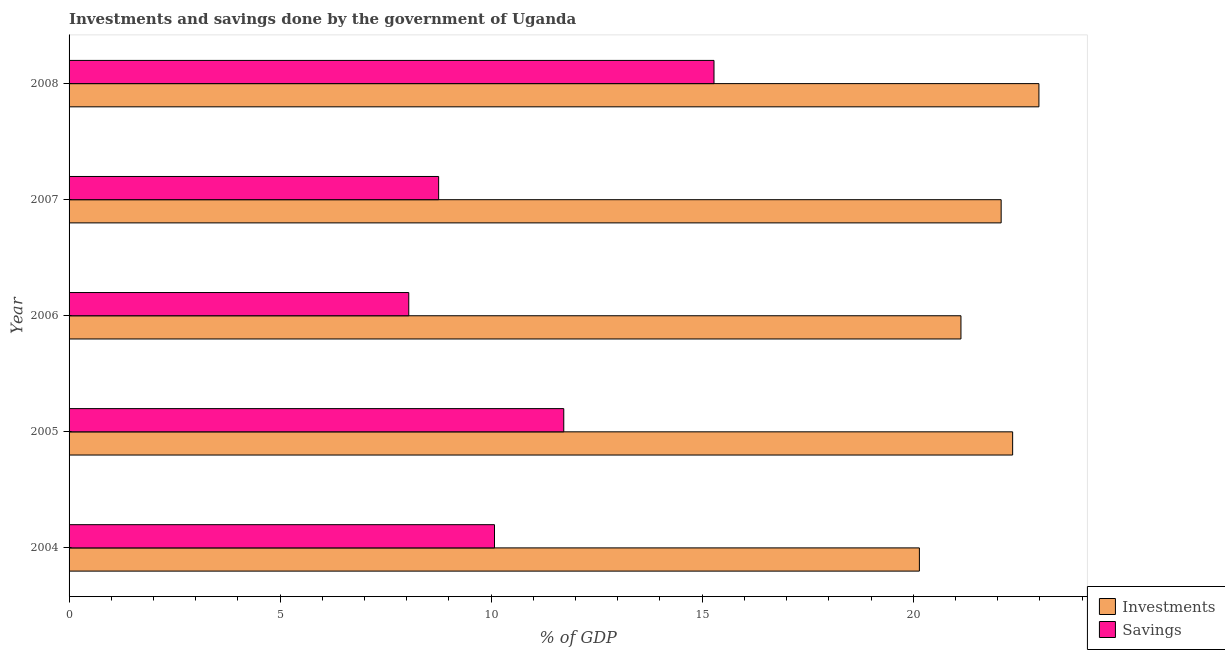How many different coloured bars are there?
Keep it short and to the point. 2. Are the number of bars per tick equal to the number of legend labels?
Keep it short and to the point. Yes. Are the number of bars on each tick of the Y-axis equal?
Offer a very short reply. Yes. How many bars are there on the 1st tick from the bottom?
Your answer should be compact. 2. What is the savings of government in 2004?
Ensure brevity in your answer.  10.08. Across all years, what is the maximum savings of government?
Your answer should be very brief. 15.28. Across all years, what is the minimum savings of government?
Make the answer very short. 8.05. In which year was the savings of government maximum?
Make the answer very short. 2008. In which year was the investments of government minimum?
Provide a succinct answer. 2004. What is the total investments of government in the graph?
Your response must be concise. 108.69. What is the difference between the investments of government in 2005 and that in 2006?
Give a very brief answer. 1.23. What is the difference between the investments of government in 2008 and the savings of government in 2004?
Your answer should be very brief. 12.9. What is the average savings of government per year?
Keep it short and to the point. 10.78. In the year 2008, what is the difference between the investments of government and savings of government?
Keep it short and to the point. 7.7. What is the ratio of the savings of government in 2004 to that in 2008?
Keep it short and to the point. 0.66. What is the difference between the highest and the second highest savings of government?
Make the answer very short. 3.56. What is the difference between the highest and the lowest savings of government?
Offer a very short reply. 7.23. In how many years, is the investments of government greater than the average investments of government taken over all years?
Give a very brief answer. 3. Is the sum of the savings of government in 2006 and 2008 greater than the maximum investments of government across all years?
Your answer should be very brief. Yes. What does the 2nd bar from the top in 2005 represents?
Keep it short and to the point. Investments. What does the 2nd bar from the bottom in 2005 represents?
Give a very brief answer. Savings. How many bars are there?
Give a very brief answer. 10. Are all the bars in the graph horizontal?
Your response must be concise. Yes. Are the values on the major ticks of X-axis written in scientific E-notation?
Provide a short and direct response. No. Does the graph contain grids?
Your answer should be very brief. No. Where does the legend appear in the graph?
Your answer should be compact. Bottom right. How many legend labels are there?
Provide a succinct answer. 2. What is the title of the graph?
Your answer should be very brief. Investments and savings done by the government of Uganda. Does "Nitrous oxide emissions" appear as one of the legend labels in the graph?
Your answer should be very brief. No. What is the label or title of the X-axis?
Your answer should be compact. % of GDP. What is the label or title of the Y-axis?
Give a very brief answer. Year. What is the % of GDP of Investments in 2004?
Your answer should be compact. 20.15. What is the % of GDP in Savings in 2004?
Provide a succinct answer. 10.08. What is the % of GDP of Investments in 2005?
Ensure brevity in your answer.  22.36. What is the % of GDP of Savings in 2005?
Offer a terse response. 11.72. What is the % of GDP in Investments in 2006?
Make the answer very short. 21.13. What is the % of GDP in Savings in 2006?
Keep it short and to the point. 8.05. What is the % of GDP in Investments in 2007?
Provide a short and direct response. 22.08. What is the % of GDP in Savings in 2007?
Keep it short and to the point. 8.76. What is the % of GDP in Investments in 2008?
Your answer should be very brief. 22.98. What is the % of GDP of Savings in 2008?
Give a very brief answer. 15.28. Across all years, what is the maximum % of GDP in Investments?
Provide a succinct answer. 22.98. Across all years, what is the maximum % of GDP in Savings?
Make the answer very short. 15.28. Across all years, what is the minimum % of GDP of Investments?
Offer a terse response. 20.15. Across all years, what is the minimum % of GDP of Savings?
Make the answer very short. 8.05. What is the total % of GDP of Investments in the graph?
Your answer should be compact. 108.69. What is the total % of GDP in Savings in the graph?
Ensure brevity in your answer.  53.88. What is the difference between the % of GDP of Investments in 2004 and that in 2005?
Make the answer very short. -2.21. What is the difference between the % of GDP of Savings in 2004 and that in 2005?
Your response must be concise. -1.64. What is the difference between the % of GDP of Investments in 2004 and that in 2006?
Ensure brevity in your answer.  -0.98. What is the difference between the % of GDP of Savings in 2004 and that in 2006?
Give a very brief answer. 2.03. What is the difference between the % of GDP in Investments in 2004 and that in 2007?
Ensure brevity in your answer.  -1.94. What is the difference between the % of GDP of Savings in 2004 and that in 2007?
Your response must be concise. 1.32. What is the difference between the % of GDP in Investments in 2004 and that in 2008?
Make the answer very short. -2.83. What is the difference between the % of GDP in Savings in 2004 and that in 2008?
Your response must be concise. -5.2. What is the difference between the % of GDP in Investments in 2005 and that in 2006?
Provide a succinct answer. 1.22. What is the difference between the % of GDP of Savings in 2005 and that in 2006?
Provide a short and direct response. 3.67. What is the difference between the % of GDP in Investments in 2005 and that in 2007?
Give a very brief answer. 0.27. What is the difference between the % of GDP in Savings in 2005 and that in 2007?
Provide a short and direct response. 2.96. What is the difference between the % of GDP in Investments in 2005 and that in 2008?
Give a very brief answer. -0.62. What is the difference between the % of GDP in Savings in 2005 and that in 2008?
Offer a very short reply. -3.56. What is the difference between the % of GDP of Investments in 2006 and that in 2007?
Provide a short and direct response. -0.95. What is the difference between the % of GDP of Savings in 2006 and that in 2007?
Provide a succinct answer. -0.71. What is the difference between the % of GDP of Investments in 2006 and that in 2008?
Your answer should be compact. -1.85. What is the difference between the % of GDP of Savings in 2006 and that in 2008?
Make the answer very short. -7.23. What is the difference between the % of GDP in Investments in 2007 and that in 2008?
Offer a very short reply. -0.89. What is the difference between the % of GDP of Savings in 2007 and that in 2008?
Give a very brief answer. -6.52. What is the difference between the % of GDP of Investments in 2004 and the % of GDP of Savings in 2005?
Ensure brevity in your answer.  8.43. What is the difference between the % of GDP in Investments in 2004 and the % of GDP in Savings in 2006?
Offer a very short reply. 12.1. What is the difference between the % of GDP of Investments in 2004 and the % of GDP of Savings in 2007?
Give a very brief answer. 11.39. What is the difference between the % of GDP of Investments in 2004 and the % of GDP of Savings in 2008?
Give a very brief answer. 4.87. What is the difference between the % of GDP in Investments in 2005 and the % of GDP in Savings in 2006?
Offer a very short reply. 14.31. What is the difference between the % of GDP in Investments in 2005 and the % of GDP in Savings in 2007?
Your answer should be very brief. 13.6. What is the difference between the % of GDP of Investments in 2005 and the % of GDP of Savings in 2008?
Keep it short and to the point. 7.08. What is the difference between the % of GDP in Investments in 2006 and the % of GDP in Savings in 2007?
Offer a terse response. 12.37. What is the difference between the % of GDP in Investments in 2006 and the % of GDP in Savings in 2008?
Your answer should be very brief. 5.85. What is the difference between the % of GDP in Investments in 2007 and the % of GDP in Savings in 2008?
Offer a very short reply. 6.8. What is the average % of GDP in Investments per year?
Provide a succinct answer. 21.74. What is the average % of GDP of Savings per year?
Offer a terse response. 10.78. In the year 2004, what is the difference between the % of GDP of Investments and % of GDP of Savings?
Ensure brevity in your answer.  10.07. In the year 2005, what is the difference between the % of GDP of Investments and % of GDP of Savings?
Provide a short and direct response. 10.63. In the year 2006, what is the difference between the % of GDP of Investments and % of GDP of Savings?
Your answer should be very brief. 13.08. In the year 2007, what is the difference between the % of GDP of Investments and % of GDP of Savings?
Your answer should be compact. 13.33. In the year 2008, what is the difference between the % of GDP in Investments and % of GDP in Savings?
Make the answer very short. 7.7. What is the ratio of the % of GDP in Investments in 2004 to that in 2005?
Provide a succinct answer. 0.9. What is the ratio of the % of GDP of Savings in 2004 to that in 2005?
Your response must be concise. 0.86. What is the ratio of the % of GDP in Investments in 2004 to that in 2006?
Make the answer very short. 0.95. What is the ratio of the % of GDP in Savings in 2004 to that in 2006?
Make the answer very short. 1.25. What is the ratio of the % of GDP of Investments in 2004 to that in 2007?
Give a very brief answer. 0.91. What is the ratio of the % of GDP in Savings in 2004 to that in 2007?
Provide a succinct answer. 1.15. What is the ratio of the % of GDP of Investments in 2004 to that in 2008?
Offer a terse response. 0.88. What is the ratio of the % of GDP of Savings in 2004 to that in 2008?
Your answer should be very brief. 0.66. What is the ratio of the % of GDP in Investments in 2005 to that in 2006?
Keep it short and to the point. 1.06. What is the ratio of the % of GDP of Savings in 2005 to that in 2006?
Provide a short and direct response. 1.46. What is the ratio of the % of GDP in Investments in 2005 to that in 2007?
Your response must be concise. 1.01. What is the ratio of the % of GDP of Savings in 2005 to that in 2007?
Offer a very short reply. 1.34. What is the ratio of the % of GDP in Investments in 2005 to that in 2008?
Provide a succinct answer. 0.97. What is the ratio of the % of GDP of Savings in 2005 to that in 2008?
Give a very brief answer. 0.77. What is the ratio of the % of GDP of Investments in 2006 to that in 2007?
Give a very brief answer. 0.96. What is the ratio of the % of GDP of Savings in 2006 to that in 2007?
Your response must be concise. 0.92. What is the ratio of the % of GDP in Investments in 2006 to that in 2008?
Keep it short and to the point. 0.92. What is the ratio of the % of GDP of Savings in 2006 to that in 2008?
Make the answer very short. 0.53. What is the ratio of the % of GDP in Investments in 2007 to that in 2008?
Your answer should be very brief. 0.96. What is the ratio of the % of GDP in Savings in 2007 to that in 2008?
Offer a terse response. 0.57. What is the difference between the highest and the second highest % of GDP in Investments?
Provide a succinct answer. 0.62. What is the difference between the highest and the second highest % of GDP of Savings?
Your answer should be compact. 3.56. What is the difference between the highest and the lowest % of GDP in Investments?
Your response must be concise. 2.83. What is the difference between the highest and the lowest % of GDP in Savings?
Your answer should be compact. 7.23. 